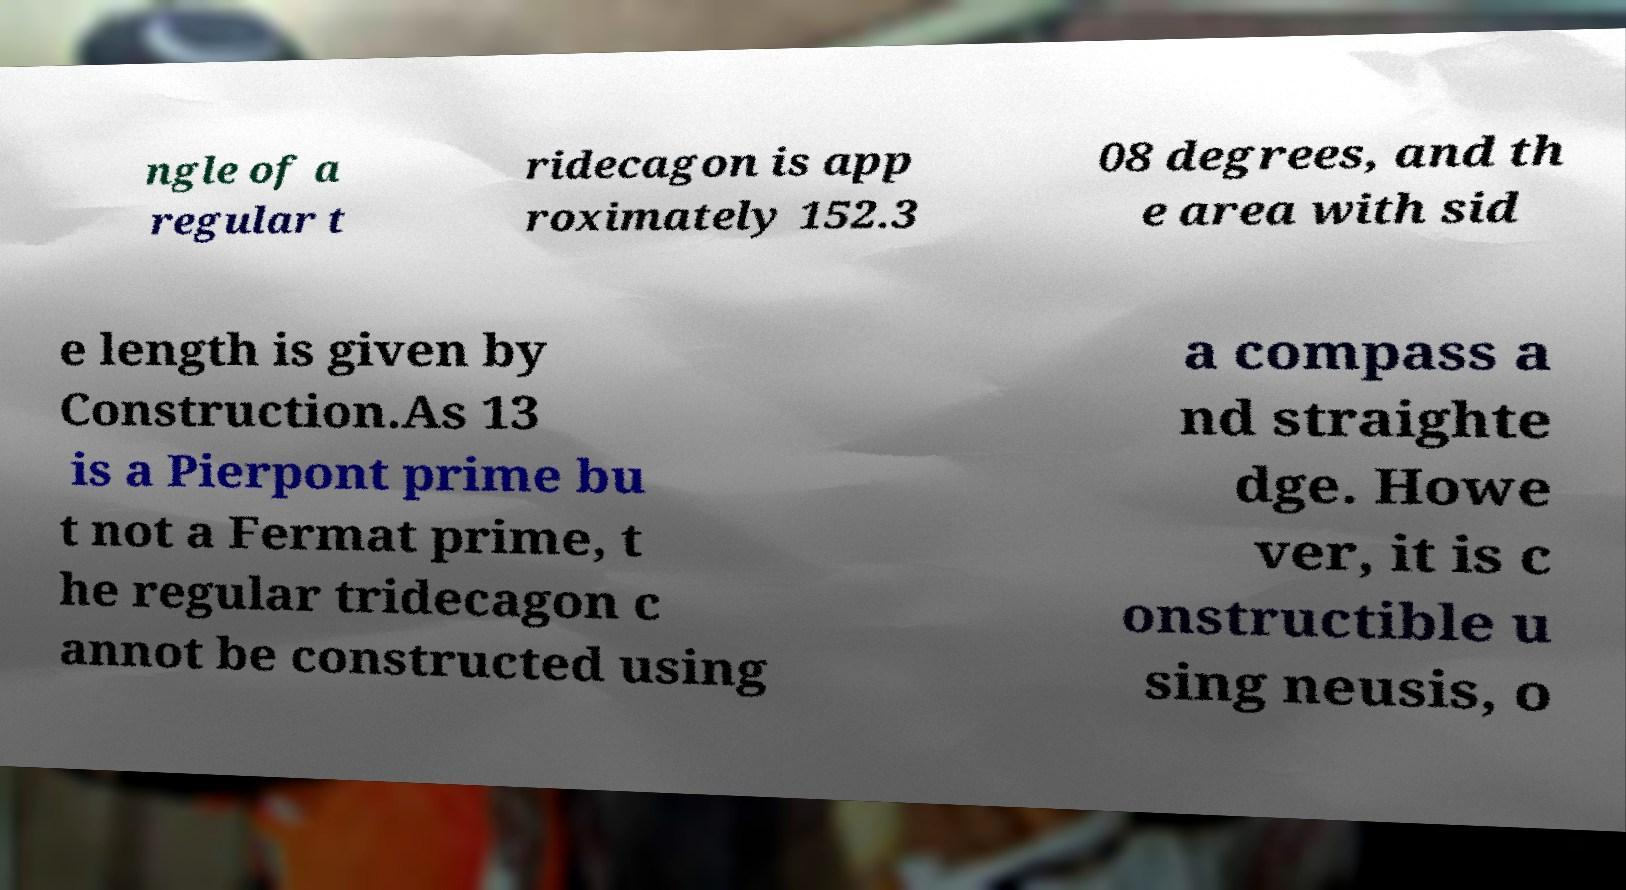Could you assist in decoding the text presented in this image and type it out clearly? ngle of a regular t ridecagon is app roximately 152.3 08 degrees, and th e area with sid e length is given by Construction.As 13 is a Pierpont prime bu t not a Fermat prime, t he regular tridecagon c annot be constructed using a compass a nd straighte dge. Howe ver, it is c onstructible u sing neusis, o 